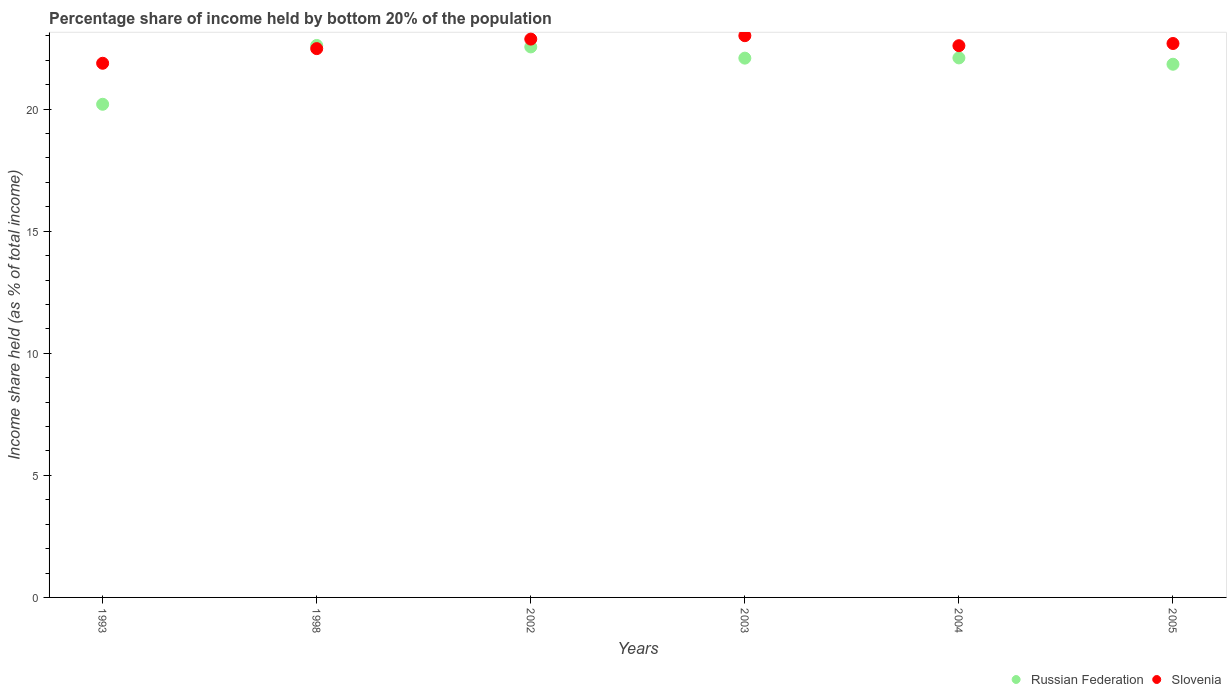How many different coloured dotlines are there?
Provide a short and direct response. 2. What is the share of income held by bottom 20% of the population in Slovenia in 2002?
Offer a terse response. 22.87. Across all years, what is the maximum share of income held by bottom 20% of the population in Slovenia?
Provide a short and direct response. 23.01. Across all years, what is the minimum share of income held by bottom 20% of the population in Russian Federation?
Your response must be concise. 20.2. In which year was the share of income held by bottom 20% of the population in Slovenia maximum?
Ensure brevity in your answer.  2003. What is the total share of income held by bottom 20% of the population in Russian Federation in the graph?
Ensure brevity in your answer.  131.39. What is the difference between the share of income held by bottom 20% of the population in Slovenia in 2002 and that in 2003?
Offer a terse response. -0.14. What is the difference between the share of income held by bottom 20% of the population in Russian Federation in 1993 and the share of income held by bottom 20% of the population in Slovenia in 1998?
Your answer should be very brief. -2.28. What is the average share of income held by bottom 20% of the population in Slovenia per year?
Ensure brevity in your answer.  22.59. In the year 2003, what is the difference between the share of income held by bottom 20% of the population in Russian Federation and share of income held by bottom 20% of the population in Slovenia?
Offer a very short reply. -0.92. In how many years, is the share of income held by bottom 20% of the population in Russian Federation greater than 21 %?
Give a very brief answer. 5. What is the ratio of the share of income held by bottom 20% of the population in Russian Federation in 2003 to that in 2005?
Offer a very short reply. 1.01. What is the difference between the highest and the second highest share of income held by bottom 20% of the population in Russian Federation?
Your answer should be compact. 0.06. What is the difference between the highest and the lowest share of income held by bottom 20% of the population in Russian Federation?
Ensure brevity in your answer.  2.41. Is the sum of the share of income held by bottom 20% of the population in Slovenia in 2002 and 2005 greater than the maximum share of income held by bottom 20% of the population in Russian Federation across all years?
Keep it short and to the point. Yes. Is the share of income held by bottom 20% of the population in Russian Federation strictly greater than the share of income held by bottom 20% of the population in Slovenia over the years?
Provide a short and direct response. No. Is the share of income held by bottom 20% of the population in Slovenia strictly less than the share of income held by bottom 20% of the population in Russian Federation over the years?
Offer a very short reply. No. How many years are there in the graph?
Keep it short and to the point. 6. Where does the legend appear in the graph?
Your answer should be very brief. Bottom right. What is the title of the graph?
Provide a succinct answer. Percentage share of income held by bottom 20% of the population. Does "Macao" appear as one of the legend labels in the graph?
Ensure brevity in your answer.  No. What is the label or title of the X-axis?
Offer a very short reply. Years. What is the label or title of the Y-axis?
Offer a terse response. Income share held (as % of total income). What is the Income share held (as % of total income) in Russian Federation in 1993?
Give a very brief answer. 20.2. What is the Income share held (as % of total income) of Slovenia in 1993?
Provide a short and direct response. 21.88. What is the Income share held (as % of total income) in Russian Federation in 1998?
Your answer should be very brief. 22.61. What is the Income share held (as % of total income) in Slovenia in 1998?
Keep it short and to the point. 22.48. What is the Income share held (as % of total income) in Russian Federation in 2002?
Give a very brief answer. 22.55. What is the Income share held (as % of total income) of Slovenia in 2002?
Make the answer very short. 22.87. What is the Income share held (as % of total income) of Russian Federation in 2003?
Give a very brief answer. 22.09. What is the Income share held (as % of total income) in Slovenia in 2003?
Offer a very short reply. 23.01. What is the Income share held (as % of total income) of Russian Federation in 2004?
Provide a short and direct response. 22.1. What is the Income share held (as % of total income) in Slovenia in 2004?
Your answer should be very brief. 22.6. What is the Income share held (as % of total income) of Russian Federation in 2005?
Keep it short and to the point. 21.84. What is the Income share held (as % of total income) in Slovenia in 2005?
Your response must be concise. 22.69. Across all years, what is the maximum Income share held (as % of total income) of Russian Federation?
Your response must be concise. 22.61. Across all years, what is the maximum Income share held (as % of total income) in Slovenia?
Provide a short and direct response. 23.01. Across all years, what is the minimum Income share held (as % of total income) of Russian Federation?
Offer a very short reply. 20.2. Across all years, what is the minimum Income share held (as % of total income) of Slovenia?
Provide a short and direct response. 21.88. What is the total Income share held (as % of total income) in Russian Federation in the graph?
Keep it short and to the point. 131.39. What is the total Income share held (as % of total income) in Slovenia in the graph?
Your answer should be very brief. 135.53. What is the difference between the Income share held (as % of total income) of Russian Federation in 1993 and that in 1998?
Keep it short and to the point. -2.41. What is the difference between the Income share held (as % of total income) of Russian Federation in 1993 and that in 2002?
Offer a very short reply. -2.35. What is the difference between the Income share held (as % of total income) in Slovenia in 1993 and that in 2002?
Your answer should be very brief. -0.99. What is the difference between the Income share held (as % of total income) in Russian Federation in 1993 and that in 2003?
Provide a short and direct response. -1.89. What is the difference between the Income share held (as % of total income) in Slovenia in 1993 and that in 2003?
Provide a succinct answer. -1.13. What is the difference between the Income share held (as % of total income) of Russian Federation in 1993 and that in 2004?
Provide a short and direct response. -1.9. What is the difference between the Income share held (as % of total income) of Slovenia in 1993 and that in 2004?
Offer a very short reply. -0.72. What is the difference between the Income share held (as % of total income) of Russian Federation in 1993 and that in 2005?
Offer a terse response. -1.64. What is the difference between the Income share held (as % of total income) in Slovenia in 1993 and that in 2005?
Offer a terse response. -0.81. What is the difference between the Income share held (as % of total income) of Slovenia in 1998 and that in 2002?
Ensure brevity in your answer.  -0.39. What is the difference between the Income share held (as % of total income) of Russian Federation in 1998 and that in 2003?
Offer a terse response. 0.52. What is the difference between the Income share held (as % of total income) in Slovenia in 1998 and that in 2003?
Keep it short and to the point. -0.53. What is the difference between the Income share held (as % of total income) in Russian Federation in 1998 and that in 2004?
Offer a very short reply. 0.51. What is the difference between the Income share held (as % of total income) of Slovenia in 1998 and that in 2004?
Provide a short and direct response. -0.12. What is the difference between the Income share held (as % of total income) of Russian Federation in 1998 and that in 2005?
Give a very brief answer. 0.77. What is the difference between the Income share held (as % of total income) of Slovenia in 1998 and that in 2005?
Give a very brief answer. -0.21. What is the difference between the Income share held (as % of total income) of Russian Federation in 2002 and that in 2003?
Your answer should be compact. 0.46. What is the difference between the Income share held (as % of total income) of Slovenia in 2002 and that in 2003?
Give a very brief answer. -0.14. What is the difference between the Income share held (as % of total income) in Russian Federation in 2002 and that in 2004?
Provide a succinct answer. 0.45. What is the difference between the Income share held (as % of total income) in Slovenia in 2002 and that in 2004?
Ensure brevity in your answer.  0.27. What is the difference between the Income share held (as % of total income) in Russian Federation in 2002 and that in 2005?
Keep it short and to the point. 0.71. What is the difference between the Income share held (as % of total income) of Slovenia in 2002 and that in 2005?
Provide a succinct answer. 0.18. What is the difference between the Income share held (as % of total income) in Russian Federation in 2003 and that in 2004?
Ensure brevity in your answer.  -0.01. What is the difference between the Income share held (as % of total income) in Slovenia in 2003 and that in 2004?
Make the answer very short. 0.41. What is the difference between the Income share held (as % of total income) in Russian Federation in 2003 and that in 2005?
Give a very brief answer. 0.25. What is the difference between the Income share held (as % of total income) in Slovenia in 2003 and that in 2005?
Offer a very short reply. 0.32. What is the difference between the Income share held (as % of total income) in Russian Federation in 2004 and that in 2005?
Your response must be concise. 0.26. What is the difference between the Income share held (as % of total income) of Slovenia in 2004 and that in 2005?
Give a very brief answer. -0.09. What is the difference between the Income share held (as % of total income) in Russian Federation in 1993 and the Income share held (as % of total income) in Slovenia in 1998?
Give a very brief answer. -2.28. What is the difference between the Income share held (as % of total income) of Russian Federation in 1993 and the Income share held (as % of total income) of Slovenia in 2002?
Ensure brevity in your answer.  -2.67. What is the difference between the Income share held (as % of total income) of Russian Federation in 1993 and the Income share held (as % of total income) of Slovenia in 2003?
Offer a terse response. -2.81. What is the difference between the Income share held (as % of total income) in Russian Federation in 1993 and the Income share held (as % of total income) in Slovenia in 2005?
Your response must be concise. -2.49. What is the difference between the Income share held (as % of total income) of Russian Federation in 1998 and the Income share held (as % of total income) of Slovenia in 2002?
Offer a terse response. -0.26. What is the difference between the Income share held (as % of total income) in Russian Federation in 1998 and the Income share held (as % of total income) in Slovenia in 2004?
Your answer should be very brief. 0.01. What is the difference between the Income share held (as % of total income) of Russian Federation in 1998 and the Income share held (as % of total income) of Slovenia in 2005?
Your answer should be compact. -0.08. What is the difference between the Income share held (as % of total income) in Russian Federation in 2002 and the Income share held (as % of total income) in Slovenia in 2003?
Your answer should be compact. -0.46. What is the difference between the Income share held (as % of total income) of Russian Federation in 2002 and the Income share held (as % of total income) of Slovenia in 2005?
Your response must be concise. -0.14. What is the difference between the Income share held (as % of total income) of Russian Federation in 2003 and the Income share held (as % of total income) of Slovenia in 2004?
Provide a short and direct response. -0.51. What is the difference between the Income share held (as % of total income) in Russian Federation in 2003 and the Income share held (as % of total income) in Slovenia in 2005?
Your answer should be compact. -0.6. What is the difference between the Income share held (as % of total income) in Russian Federation in 2004 and the Income share held (as % of total income) in Slovenia in 2005?
Provide a short and direct response. -0.59. What is the average Income share held (as % of total income) in Russian Federation per year?
Provide a succinct answer. 21.9. What is the average Income share held (as % of total income) in Slovenia per year?
Offer a terse response. 22.59. In the year 1993, what is the difference between the Income share held (as % of total income) in Russian Federation and Income share held (as % of total income) in Slovenia?
Keep it short and to the point. -1.68. In the year 1998, what is the difference between the Income share held (as % of total income) of Russian Federation and Income share held (as % of total income) of Slovenia?
Your answer should be very brief. 0.13. In the year 2002, what is the difference between the Income share held (as % of total income) of Russian Federation and Income share held (as % of total income) of Slovenia?
Give a very brief answer. -0.32. In the year 2003, what is the difference between the Income share held (as % of total income) of Russian Federation and Income share held (as % of total income) of Slovenia?
Make the answer very short. -0.92. In the year 2005, what is the difference between the Income share held (as % of total income) in Russian Federation and Income share held (as % of total income) in Slovenia?
Your response must be concise. -0.85. What is the ratio of the Income share held (as % of total income) in Russian Federation in 1993 to that in 1998?
Your answer should be very brief. 0.89. What is the ratio of the Income share held (as % of total income) of Slovenia in 1993 to that in 1998?
Ensure brevity in your answer.  0.97. What is the ratio of the Income share held (as % of total income) of Russian Federation in 1993 to that in 2002?
Ensure brevity in your answer.  0.9. What is the ratio of the Income share held (as % of total income) in Slovenia in 1993 to that in 2002?
Your answer should be very brief. 0.96. What is the ratio of the Income share held (as % of total income) of Russian Federation in 1993 to that in 2003?
Make the answer very short. 0.91. What is the ratio of the Income share held (as % of total income) in Slovenia in 1993 to that in 2003?
Make the answer very short. 0.95. What is the ratio of the Income share held (as % of total income) in Russian Federation in 1993 to that in 2004?
Your response must be concise. 0.91. What is the ratio of the Income share held (as % of total income) in Slovenia in 1993 to that in 2004?
Give a very brief answer. 0.97. What is the ratio of the Income share held (as % of total income) of Russian Federation in 1993 to that in 2005?
Offer a terse response. 0.92. What is the ratio of the Income share held (as % of total income) in Russian Federation in 1998 to that in 2002?
Your answer should be compact. 1. What is the ratio of the Income share held (as % of total income) in Slovenia in 1998 to that in 2002?
Your answer should be compact. 0.98. What is the ratio of the Income share held (as % of total income) in Russian Federation in 1998 to that in 2003?
Your answer should be very brief. 1.02. What is the ratio of the Income share held (as % of total income) of Slovenia in 1998 to that in 2003?
Ensure brevity in your answer.  0.98. What is the ratio of the Income share held (as % of total income) of Russian Federation in 1998 to that in 2004?
Your response must be concise. 1.02. What is the ratio of the Income share held (as % of total income) in Slovenia in 1998 to that in 2004?
Keep it short and to the point. 0.99. What is the ratio of the Income share held (as % of total income) in Russian Federation in 1998 to that in 2005?
Keep it short and to the point. 1.04. What is the ratio of the Income share held (as % of total income) of Slovenia in 1998 to that in 2005?
Your response must be concise. 0.99. What is the ratio of the Income share held (as % of total income) of Russian Federation in 2002 to that in 2003?
Give a very brief answer. 1.02. What is the ratio of the Income share held (as % of total income) of Russian Federation in 2002 to that in 2004?
Give a very brief answer. 1.02. What is the ratio of the Income share held (as % of total income) in Slovenia in 2002 to that in 2004?
Your answer should be very brief. 1.01. What is the ratio of the Income share held (as % of total income) in Russian Federation in 2002 to that in 2005?
Offer a very short reply. 1.03. What is the ratio of the Income share held (as % of total income) of Slovenia in 2002 to that in 2005?
Your response must be concise. 1.01. What is the ratio of the Income share held (as % of total income) of Russian Federation in 2003 to that in 2004?
Give a very brief answer. 1. What is the ratio of the Income share held (as % of total income) in Slovenia in 2003 to that in 2004?
Your answer should be compact. 1.02. What is the ratio of the Income share held (as % of total income) in Russian Federation in 2003 to that in 2005?
Keep it short and to the point. 1.01. What is the ratio of the Income share held (as % of total income) of Slovenia in 2003 to that in 2005?
Your answer should be compact. 1.01. What is the ratio of the Income share held (as % of total income) in Russian Federation in 2004 to that in 2005?
Your answer should be very brief. 1.01. What is the ratio of the Income share held (as % of total income) of Slovenia in 2004 to that in 2005?
Your answer should be compact. 1. What is the difference between the highest and the second highest Income share held (as % of total income) of Russian Federation?
Your answer should be compact. 0.06. What is the difference between the highest and the second highest Income share held (as % of total income) of Slovenia?
Keep it short and to the point. 0.14. What is the difference between the highest and the lowest Income share held (as % of total income) of Russian Federation?
Offer a terse response. 2.41. What is the difference between the highest and the lowest Income share held (as % of total income) of Slovenia?
Ensure brevity in your answer.  1.13. 